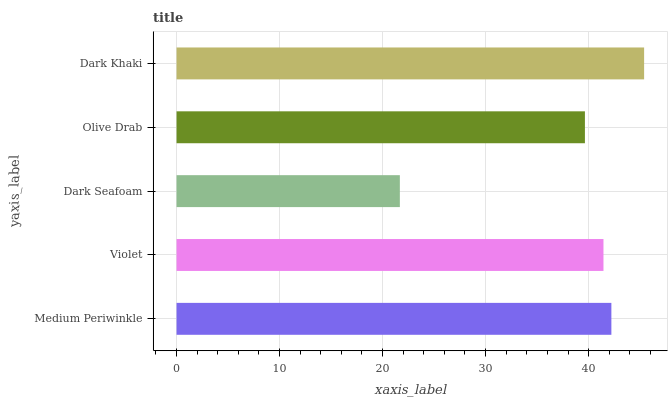Is Dark Seafoam the minimum?
Answer yes or no. Yes. Is Dark Khaki the maximum?
Answer yes or no. Yes. Is Violet the minimum?
Answer yes or no. No. Is Violet the maximum?
Answer yes or no. No. Is Medium Periwinkle greater than Violet?
Answer yes or no. Yes. Is Violet less than Medium Periwinkle?
Answer yes or no. Yes. Is Violet greater than Medium Periwinkle?
Answer yes or no. No. Is Medium Periwinkle less than Violet?
Answer yes or no. No. Is Violet the high median?
Answer yes or no. Yes. Is Violet the low median?
Answer yes or no. Yes. Is Olive Drab the high median?
Answer yes or no. No. Is Olive Drab the low median?
Answer yes or no. No. 